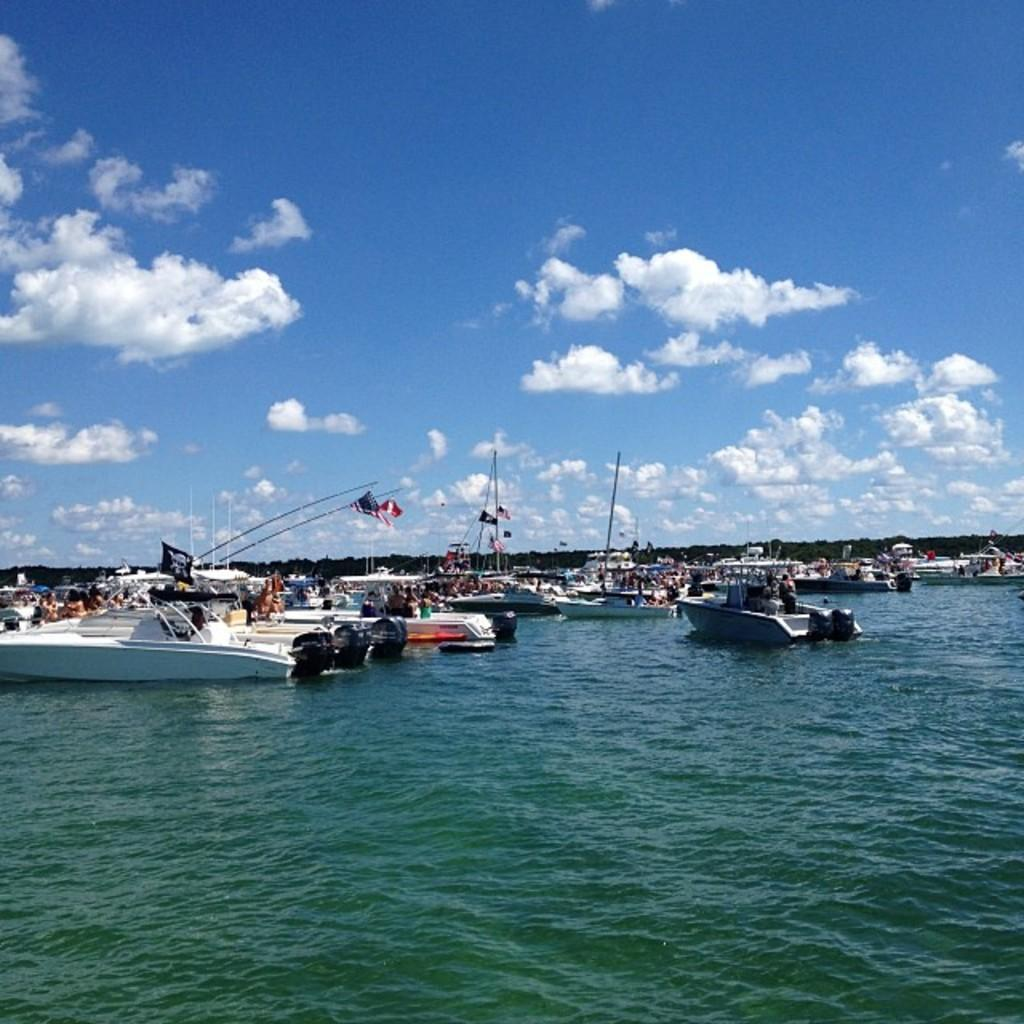What is the primary element in the image? There is water in the image. What is present on the water? There are boats on the water. What can be seen in the distance in the image? Hills are visible in the background of the image. What else is visible in the background of the image? The sky is visible in the background of the image. What type of fowl can be seen joining the boats in the image? There is no fowl present in the image, and no fowl is joining the boats. 